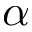Convert formula to latex. <formula><loc_0><loc_0><loc_500><loc_500>\alpha</formula> 